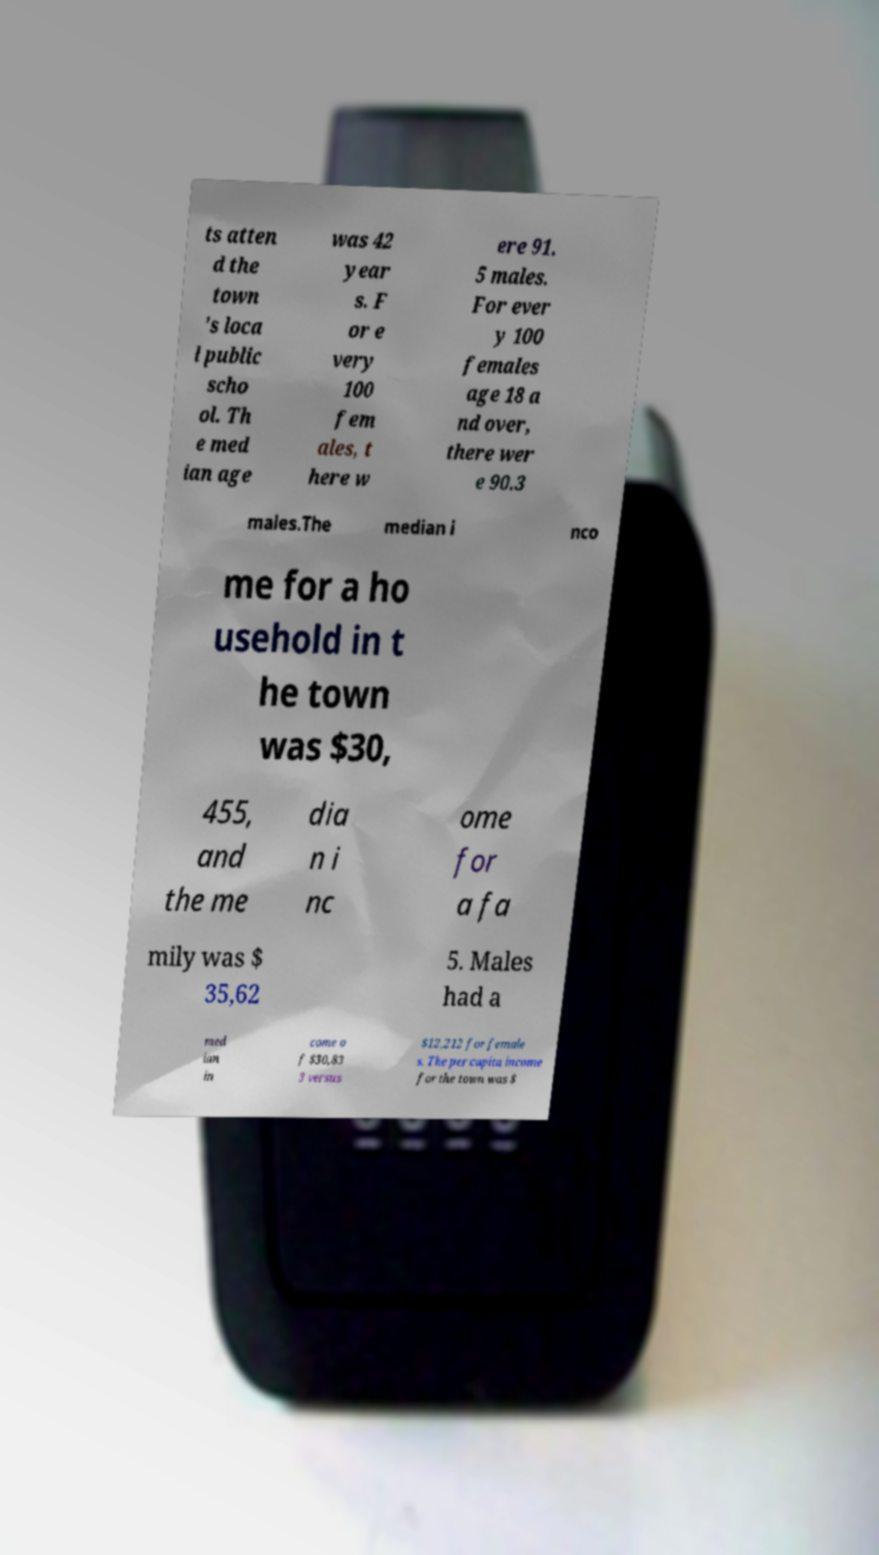Could you assist in decoding the text presented in this image and type it out clearly? ts atten d the town 's loca l public scho ol. Th e med ian age was 42 year s. F or e very 100 fem ales, t here w ere 91. 5 males. For ever y 100 females age 18 a nd over, there wer e 90.3 males.The median i nco me for a ho usehold in t he town was $30, 455, and the me dia n i nc ome for a fa mily was $ 35,62 5. Males had a med ian in come o f $30,83 3 versus $12,212 for female s. The per capita income for the town was $ 